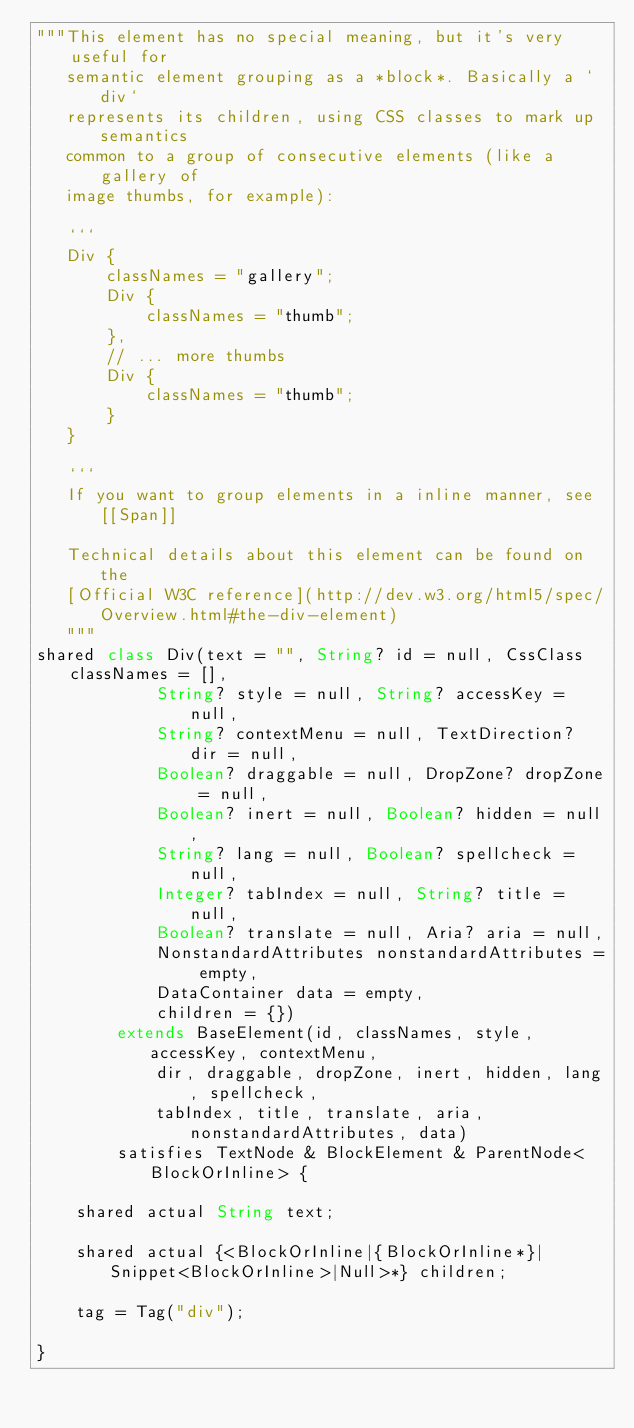Convert code to text. <code><loc_0><loc_0><loc_500><loc_500><_Ceylon_>"""This element has no special meaning, but it's very useful for
   semantic element grouping as a *block*. Basically a `div`
   represents its children, using CSS classes to mark up semantics
   common to a group of consecutive elements (like a gallery of
   image thumbs, for example):

   ```
   Div {
       classNames = "gallery";
       Div {
           classNames = "thumb";
       },
       // ... more thumbs
       Div {
           classNames = "thumb";
       }
   }

   ```
   If you want to group elements in a inline manner, see [[Span]]
   
   Technical details about this element can be found on the
   [Official W3C reference](http://dev.w3.org/html5/spec/Overview.html#the-div-element)
   """
shared class Div(text = "", String? id = null, CssClass classNames = [],
            String? style = null, String? accessKey = null,
            String? contextMenu = null, TextDirection? dir = null,
            Boolean? draggable = null, DropZone? dropZone = null,
            Boolean? inert = null, Boolean? hidden = null,
            String? lang = null, Boolean? spellcheck = null,
            Integer? tabIndex = null, String? title = null,
            Boolean? translate = null, Aria? aria = null,
            NonstandardAttributes nonstandardAttributes = empty,
            DataContainer data = empty,
            children = {})
        extends BaseElement(id, classNames, style, accessKey, contextMenu,
            dir, draggable, dropZone, inert, hidden, lang, spellcheck,
            tabIndex, title, translate, aria, nonstandardAttributes, data)
        satisfies TextNode & BlockElement & ParentNode<BlockOrInline> {

    shared actual String text;

    shared actual {<BlockOrInline|{BlockOrInline*}|Snippet<BlockOrInline>|Null>*} children;

    tag = Tag("div");

}
</code> 